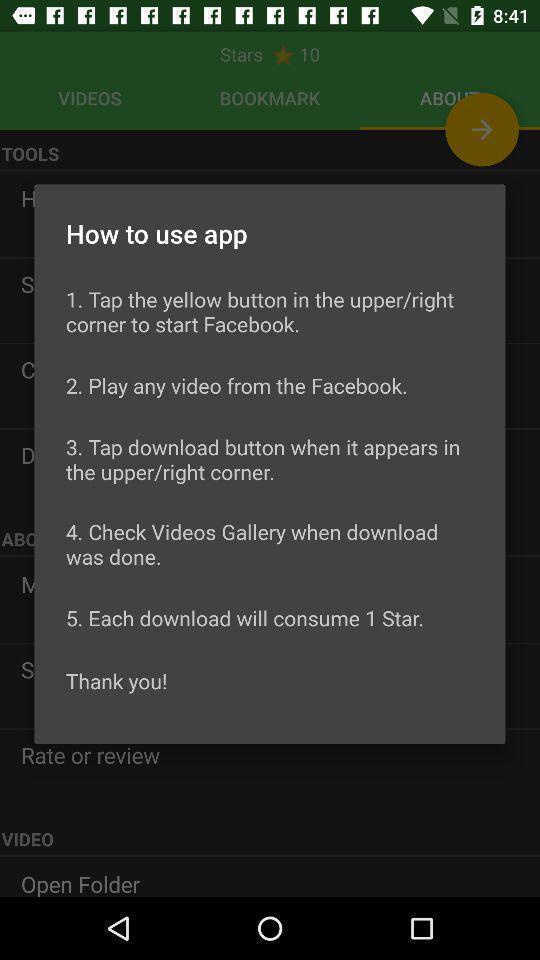Explain the elements present in this screenshot. Pop-up shows number of uses. 